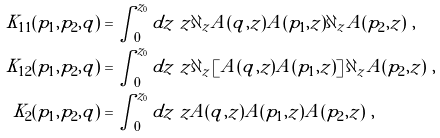<formula> <loc_0><loc_0><loc_500><loc_500>K _ { 1 1 } ( p _ { 1 } , p _ { 2 } , q ) & = \int ^ { z _ { 0 } } _ { 0 } d z \ z \partial _ { z } A ( q , z ) A ( p _ { 1 } , z ) \partial _ { z } A ( p _ { 2 } , z ) \ , \\ K _ { 1 2 } ( p _ { 1 } , p _ { 2 } , q ) & = \int ^ { z _ { 0 } } _ { 0 } d z \ z \partial _ { z } \left [ A ( q , z ) A ( p _ { 1 } , z ) \right ] \partial _ { z } A ( p _ { 2 } , z ) \ , \\ K _ { 2 } ( p _ { 1 } , p _ { 2 } , q ) & = \int ^ { z _ { 0 } } _ { 0 } d z \ z A ( q , z ) A ( p _ { 1 } , z ) A ( p _ { 2 } , z ) \ ,</formula> 